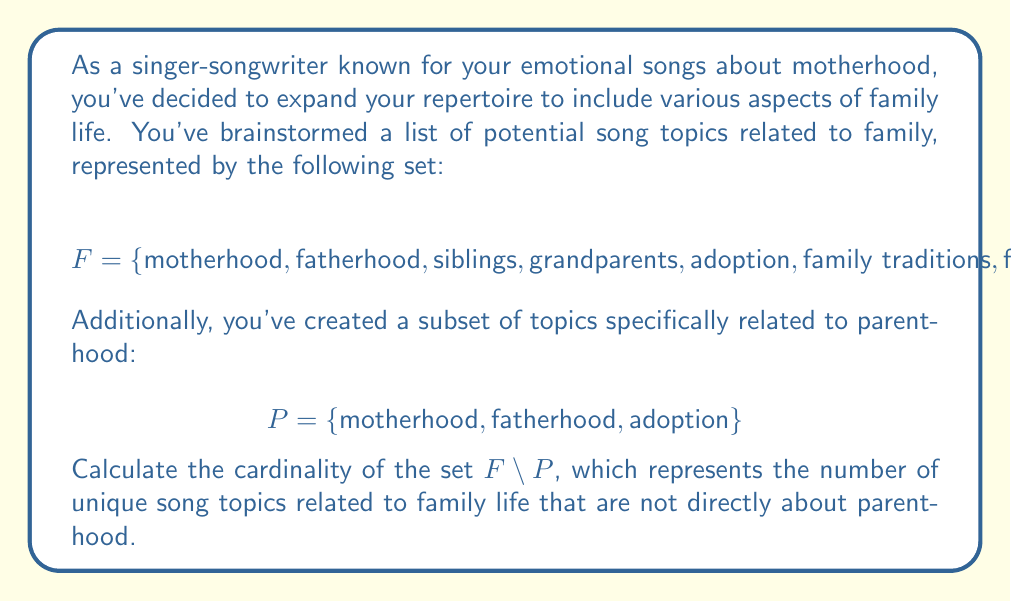Can you solve this math problem? To solve this problem, we'll follow these steps:

1) First, recall that the set difference $F \setminus P$ contains all elements of $F$ that are not in $P$.

2) Let's identify the elements in $F$ that are not in $P$:
   - siblings
   - grandparents
   - family traditions
   - family vacations

3) The cardinality of a set is the number of elements in the set. We can denote this using vertical bars, like this: $|F \setminus P|$

4) Count the number of elements we identified in step 2:
   $$|F \setminus P| = 4$$

Therefore, there are 4 unique song topics related to family life that are not directly about parenthood.
Answer: $4$ 